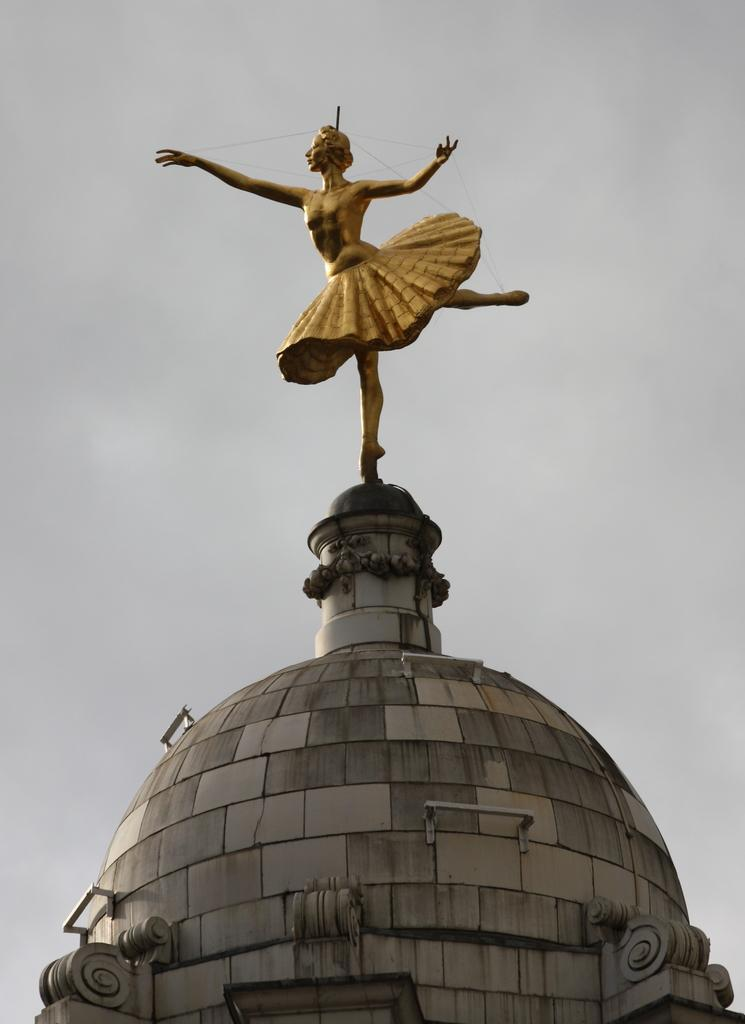What type of structure is present in the image? There is a historical construction in the image. What feature can be seen on the historical construction? The historical construction has rods. What other object is visible in the image? There is a statue in the image. What can be seen in the background of the image? The sky is visible in the background of the image. What type of wood is used to build the foot of the statue in the image? There is no mention of a foot on the statue in the image, nor is there any information about the materials used in its construction. 